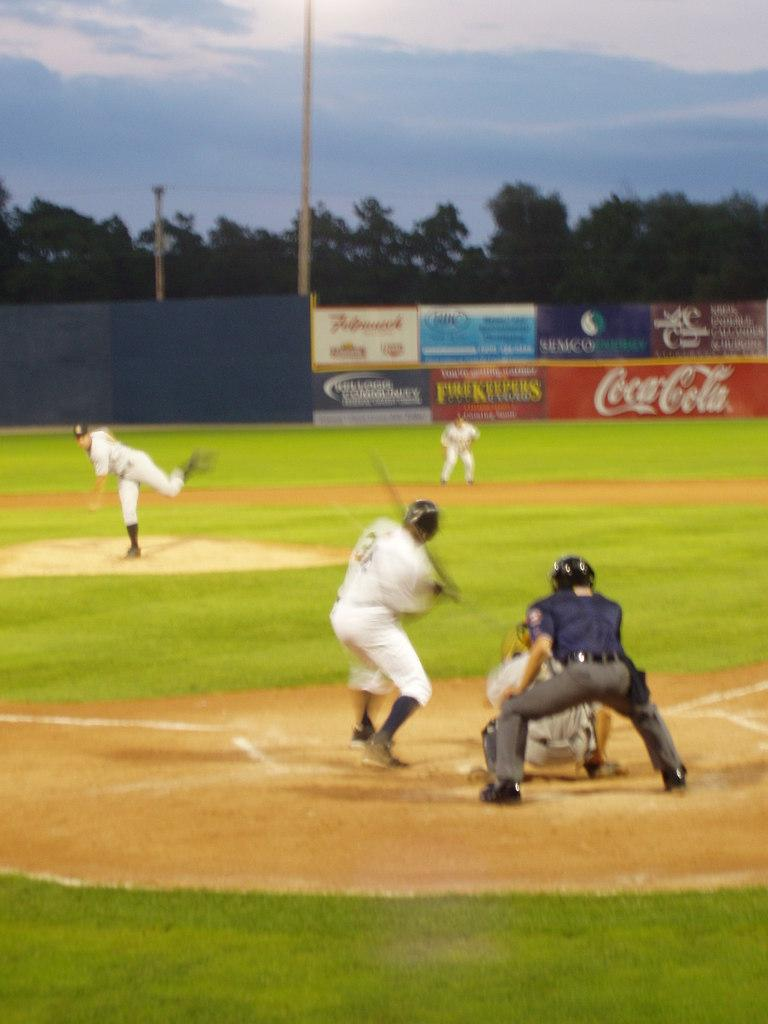<image>
Render a clear and concise summary of the photo. baseball game where one of the sponsors is coca-cola 